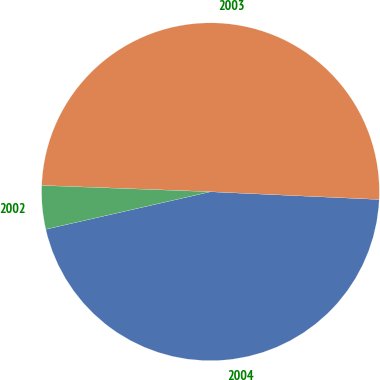<chart> <loc_0><loc_0><loc_500><loc_500><pie_chart><fcel>2004<fcel>2003<fcel>2002<nl><fcel>45.7%<fcel>50.13%<fcel>4.16%<nl></chart> 